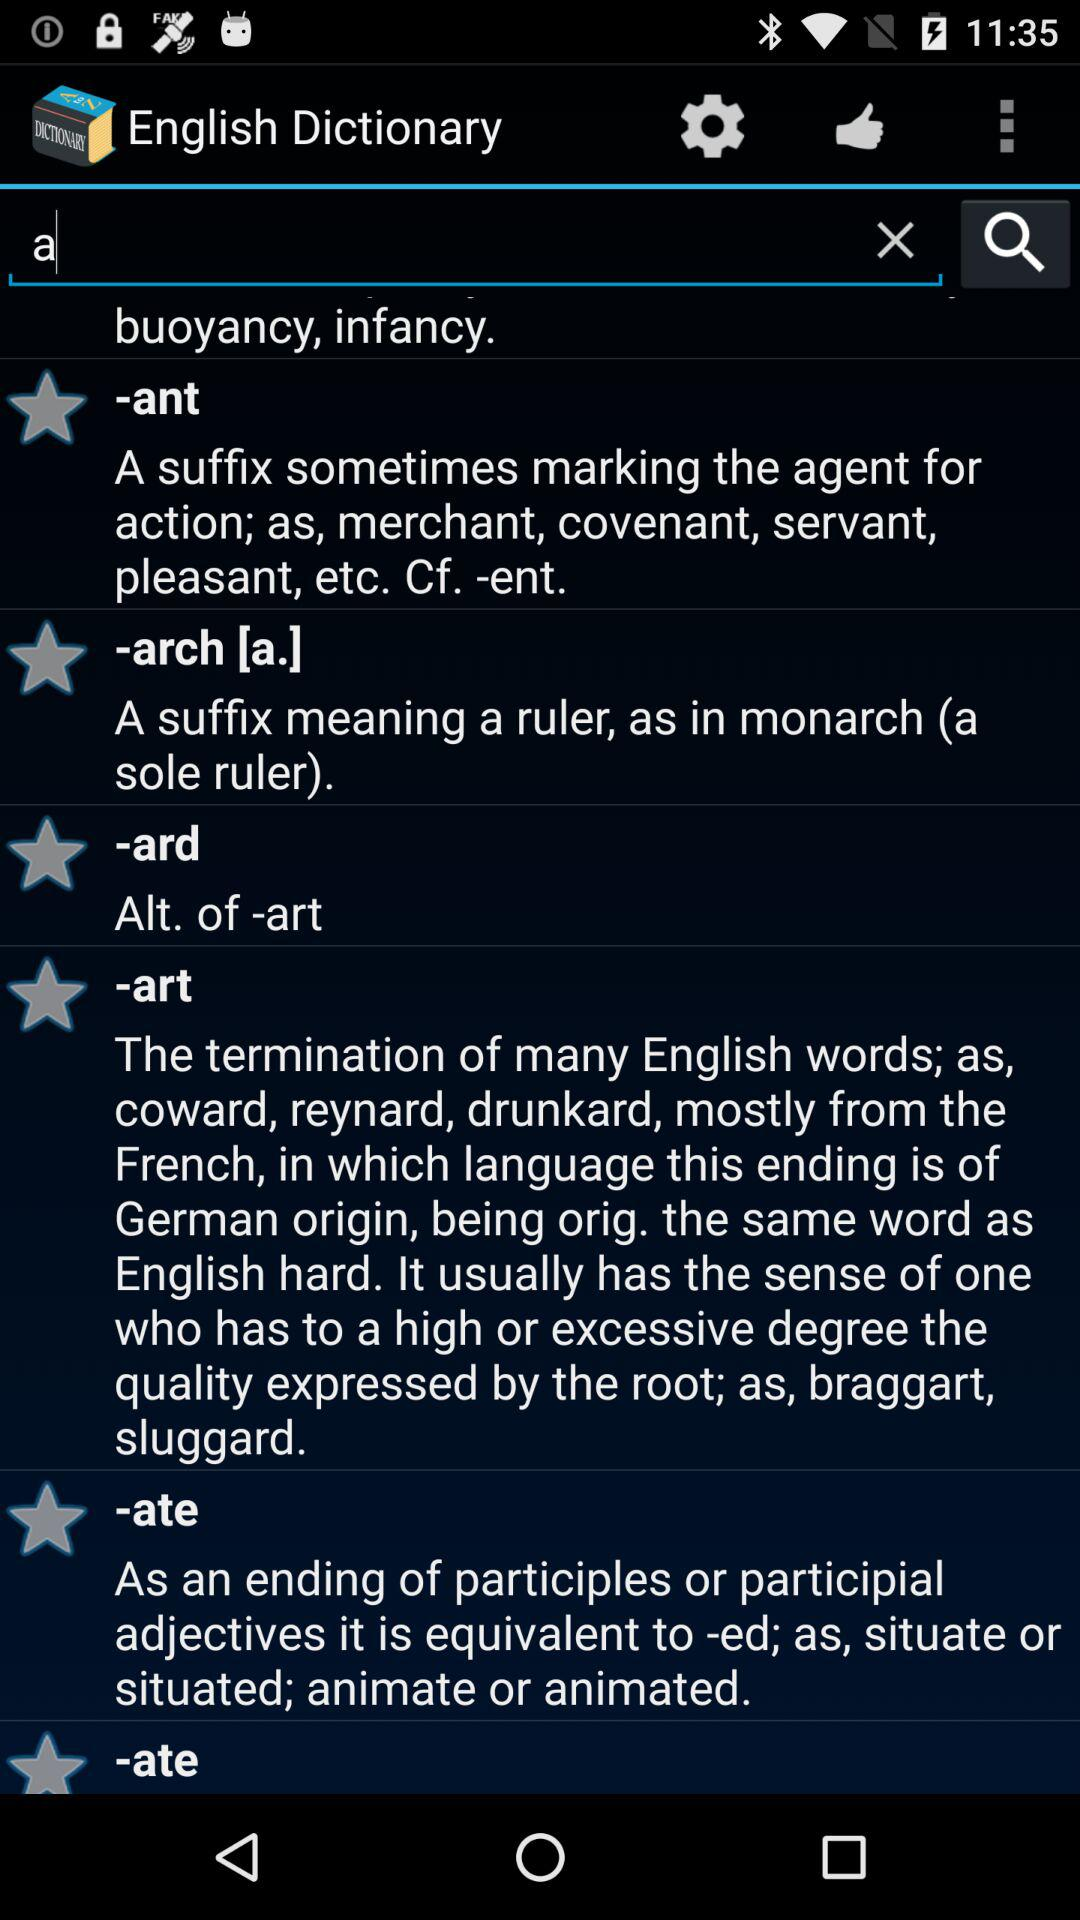What is the name of the application? The name of the application is "English Dictionary". 